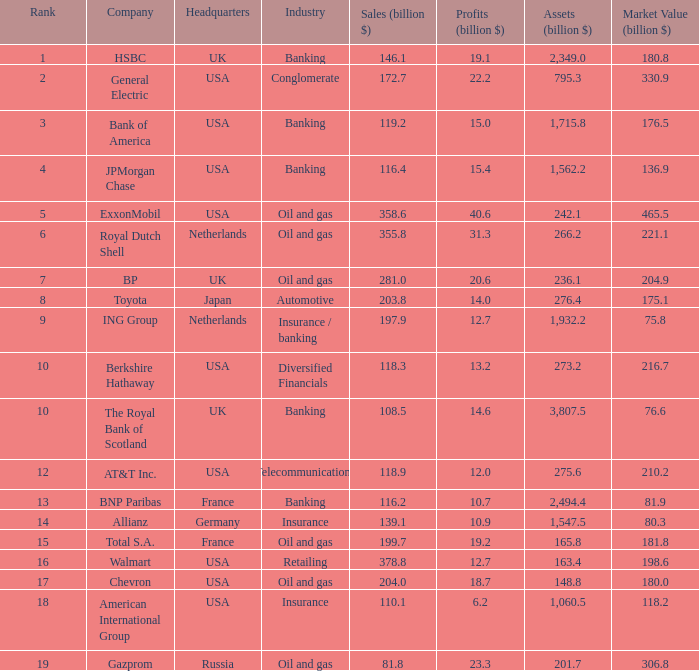3 billion market worth? Insurance. 